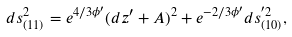Convert formula to latex. <formula><loc_0><loc_0><loc_500><loc_500>d s ^ { 2 } _ { ( 1 1 ) } = e ^ { 4 / 3 \phi ^ { \prime } } ( d z ^ { \prime } + A ) ^ { 2 } + e ^ { - 2 / 3 \phi ^ { \prime } } d s ^ { ^ { \prime } 2 } _ { ( 1 0 ) } ,</formula> 